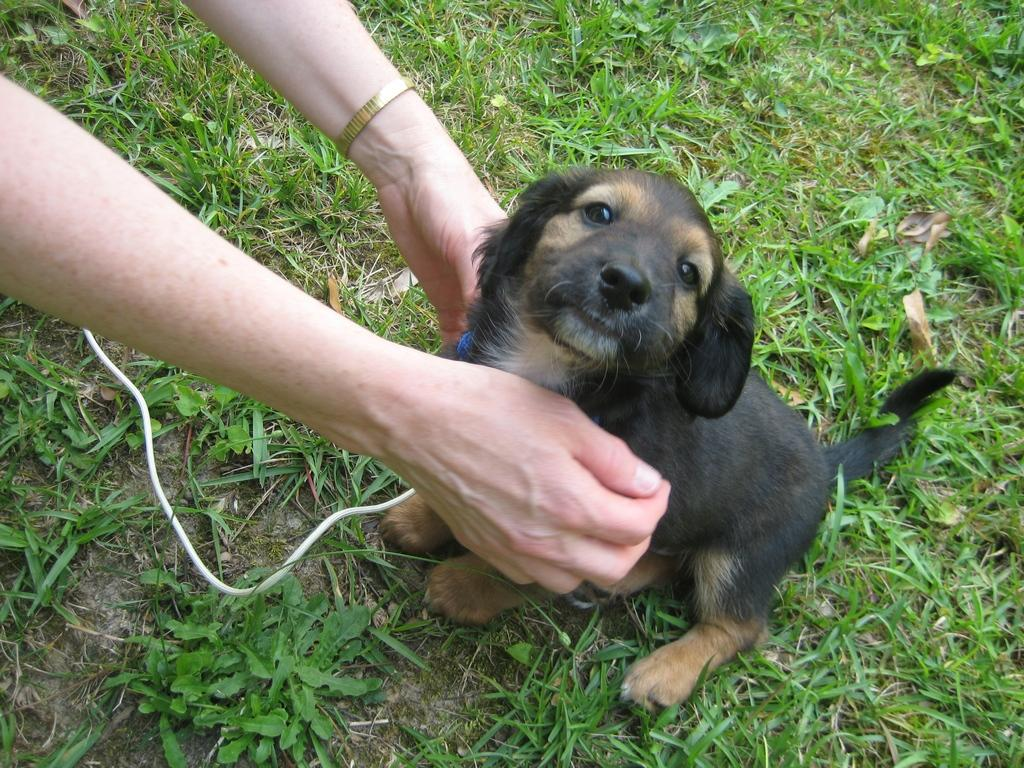Who or what is the main subject in the image? There is a person in the image. What is the person holding? The person is holding a dog. Can you describe the dog's appearance? The dog is brown and black in color. What can be seen in the background of the image? There is grass and a wire in the background of the image. How many rabbits can be seen playing with a tin in the image? There are no rabbits or tin present in the image. Is there an arch visible in the background of the image? There is no arch visible in the background of the image; only grass and a wire are present. 